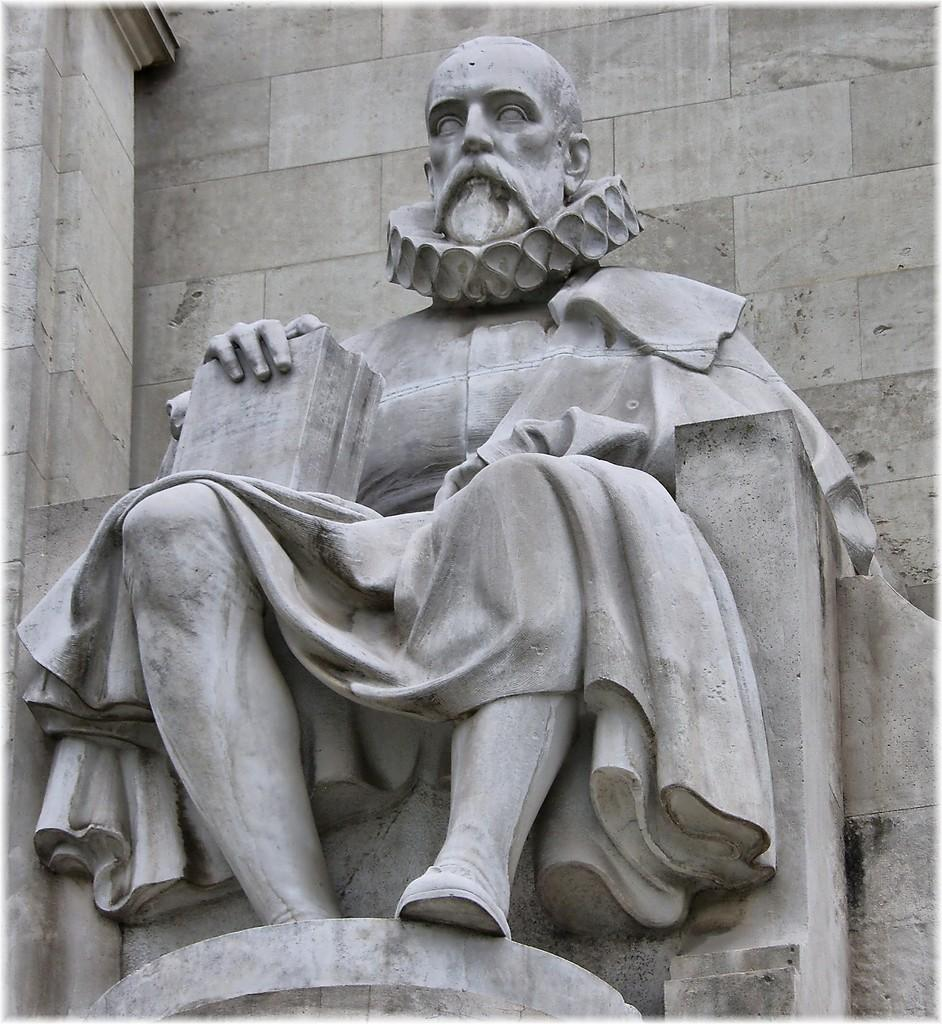What is the main subject of the image? There is a statue of a person in the image. What is the person in the statue doing? The person is sitting. What object is the person holding in the image? The person is holding a book in his hand. What can be seen behind the statue? There is a wall behind the statue. Can you describe the hen that is attacking the statue in the image? There is no hen present in the image, nor is there any indication of an attack. 